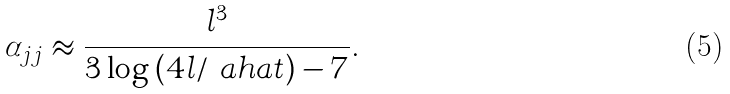Convert formula to latex. <formula><loc_0><loc_0><loc_500><loc_500>\alpha _ { j j } \approx \frac { l ^ { 3 } } { 3 \log \left ( 4 l / \ a h a t \right ) - 7 } .</formula> 